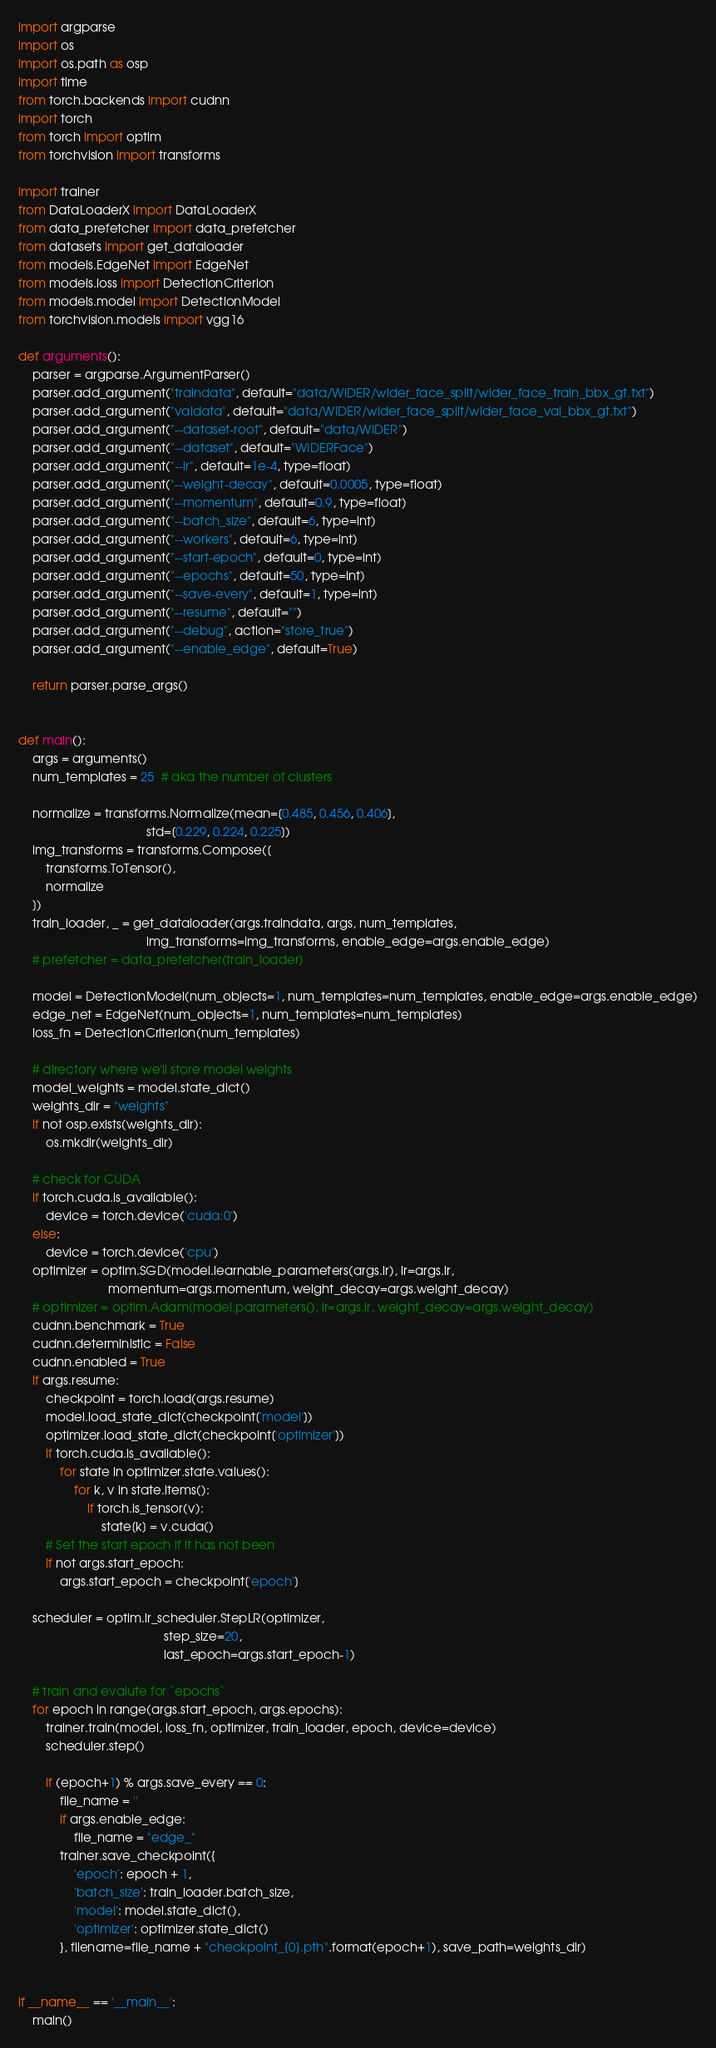Convert code to text. <code><loc_0><loc_0><loc_500><loc_500><_Python_>import argparse
import os
import os.path as osp
import time
from torch.backends import cudnn
import torch
from torch import optim
from torchvision import transforms

import trainer
from DataLoaderX import DataLoaderX
from data_prefetcher import data_prefetcher
from datasets import get_dataloader
from models.EdgeNet import EdgeNet
from models.loss import DetectionCriterion
from models.model import DetectionModel
from torchvision.models import vgg16

def arguments():
    parser = argparse.ArgumentParser()
    parser.add_argument("traindata", default="data/WIDER/wider_face_split/wider_face_train_bbx_gt.txt")
    parser.add_argument("valdata", default="data/WIDER/wider_face_split/wider_face_val_bbx_gt.txt")
    parser.add_argument("--dataset-root", default="data/WIDER")
    parser.add_argument("--dataset", default="WIDERFace")
    parser.add_argument("--lr", default=1e-4, type=float)
    parser.add_argument("--weight-decay", default=0.0005, type=float)
    parser.add_argument("--momentum", default=0.9, type=float)
    parser.add_argument("--batch_size", default=6, type=int)
    parser.add_argument("--workers", default=6, type=int)
    parser.add_argument("--start-epoch", default=0, type=int)
    parser.add_argument("--epochs", default=50, type=int)
    parser.add_argument("--save-every", default=1, type=int)
    parser.add_argument("--resume", default="")
    parser.add_argument("--debug", action="store_true")
    parser.add_argument("--enable_edge", default=True)

    return parser.parse_args()


def main():
    args = arguments()
    num_templates = 25  # aka the number of clusters

    normalize = transforms.Normalize(mean=[0.485, 0.456, 0.406],
                                     std=[0.229, 0.224, 0.225])
    img_transforms = transforms.Compose([
        transforms.ToTensor(),
        normalize
    ])
    train_loader, _ = get_dataloader(args.traindata, args, num_templates,
                                     img_transforms=img_transforms, enable_edge=args.enable_edge)
    # prefetcher = data_prefetcher(train_loader)

    model = DetectionModel(num_objects=1, num_templates=num_templates, enable_edge=args.enable_edge)
    edge_net = EdgeNet(num_objects=1, num_templates=num_templates)
    loss_fn = DetectionCriterion(num_templates)

    # directory where we'll store model weights
    model_weights = model.state_dict()
    weights_dir = "weights"
    if not osp.exists(weights_dir):
        os.mkdir(weights_dir)

    # check for CUDA
    if torch.cuda.is_available():
        device = torch.device('cuda:0')
    else:
        device = torch.device('cpu')
    optimizer = optim.SGD(model.learnable_parameters(args.lr), lr=args.lr,
                          momentum=args.momentum, weight_decay=args.weight_decay)
    # optimizer = optim.Adam(model.parameters(), lr=args.lr, weight_decay=args.weight_decay)
    cudnn.benchmark = True
    cudnn.deterministic = False
    cudnn.enabled = True
    if args.resume:
        checkpoint = torch.load(args.resume)
        model.load_state_dict(checkpoint['model'])
        optimizer.load_state_dict(checkpoint['optimizer'])
        if torch.cuda.is_available():
            for state in optimizer.state.values():
                for k, v in state.items():
                    if torch.is_tensor(v):
                        state[k] = v.cuda()
        # Set the start epoch if it has not been
        if not args.start_epoch:
            args.start_epoch = checkpoint['epoch']

    scheduler = optim.lr_scheduler.StepLR(optimizer,
                                          step_size=20,
                                          last_epoch=args.start_epoch-1)

    # train and evalute for `epochs`
    for epoch in range(args.start_epoch, args.epochs):
        trainer.train(model, loss_fn, optimizer, train_loader, epoch, device=device)
        scheduler.step()

        if (epoch+1) % args.save_every == 0:
            file_name = ''
            if args.enable_edge:
                file_name = "edge_"
            trainer.save_checkpoint({
                'epoch': epoch + 1,
                'batch_size': train_loader.batch_size,
                'model': model.state_dict(),
                'optimizer': optimizer.state_dict()
            }, filename=file_name + "checkpoint_{0}.pth".format(epoch+1), save_path=weights_dir)


if __name__ == '__main__':
    main()
</code> 